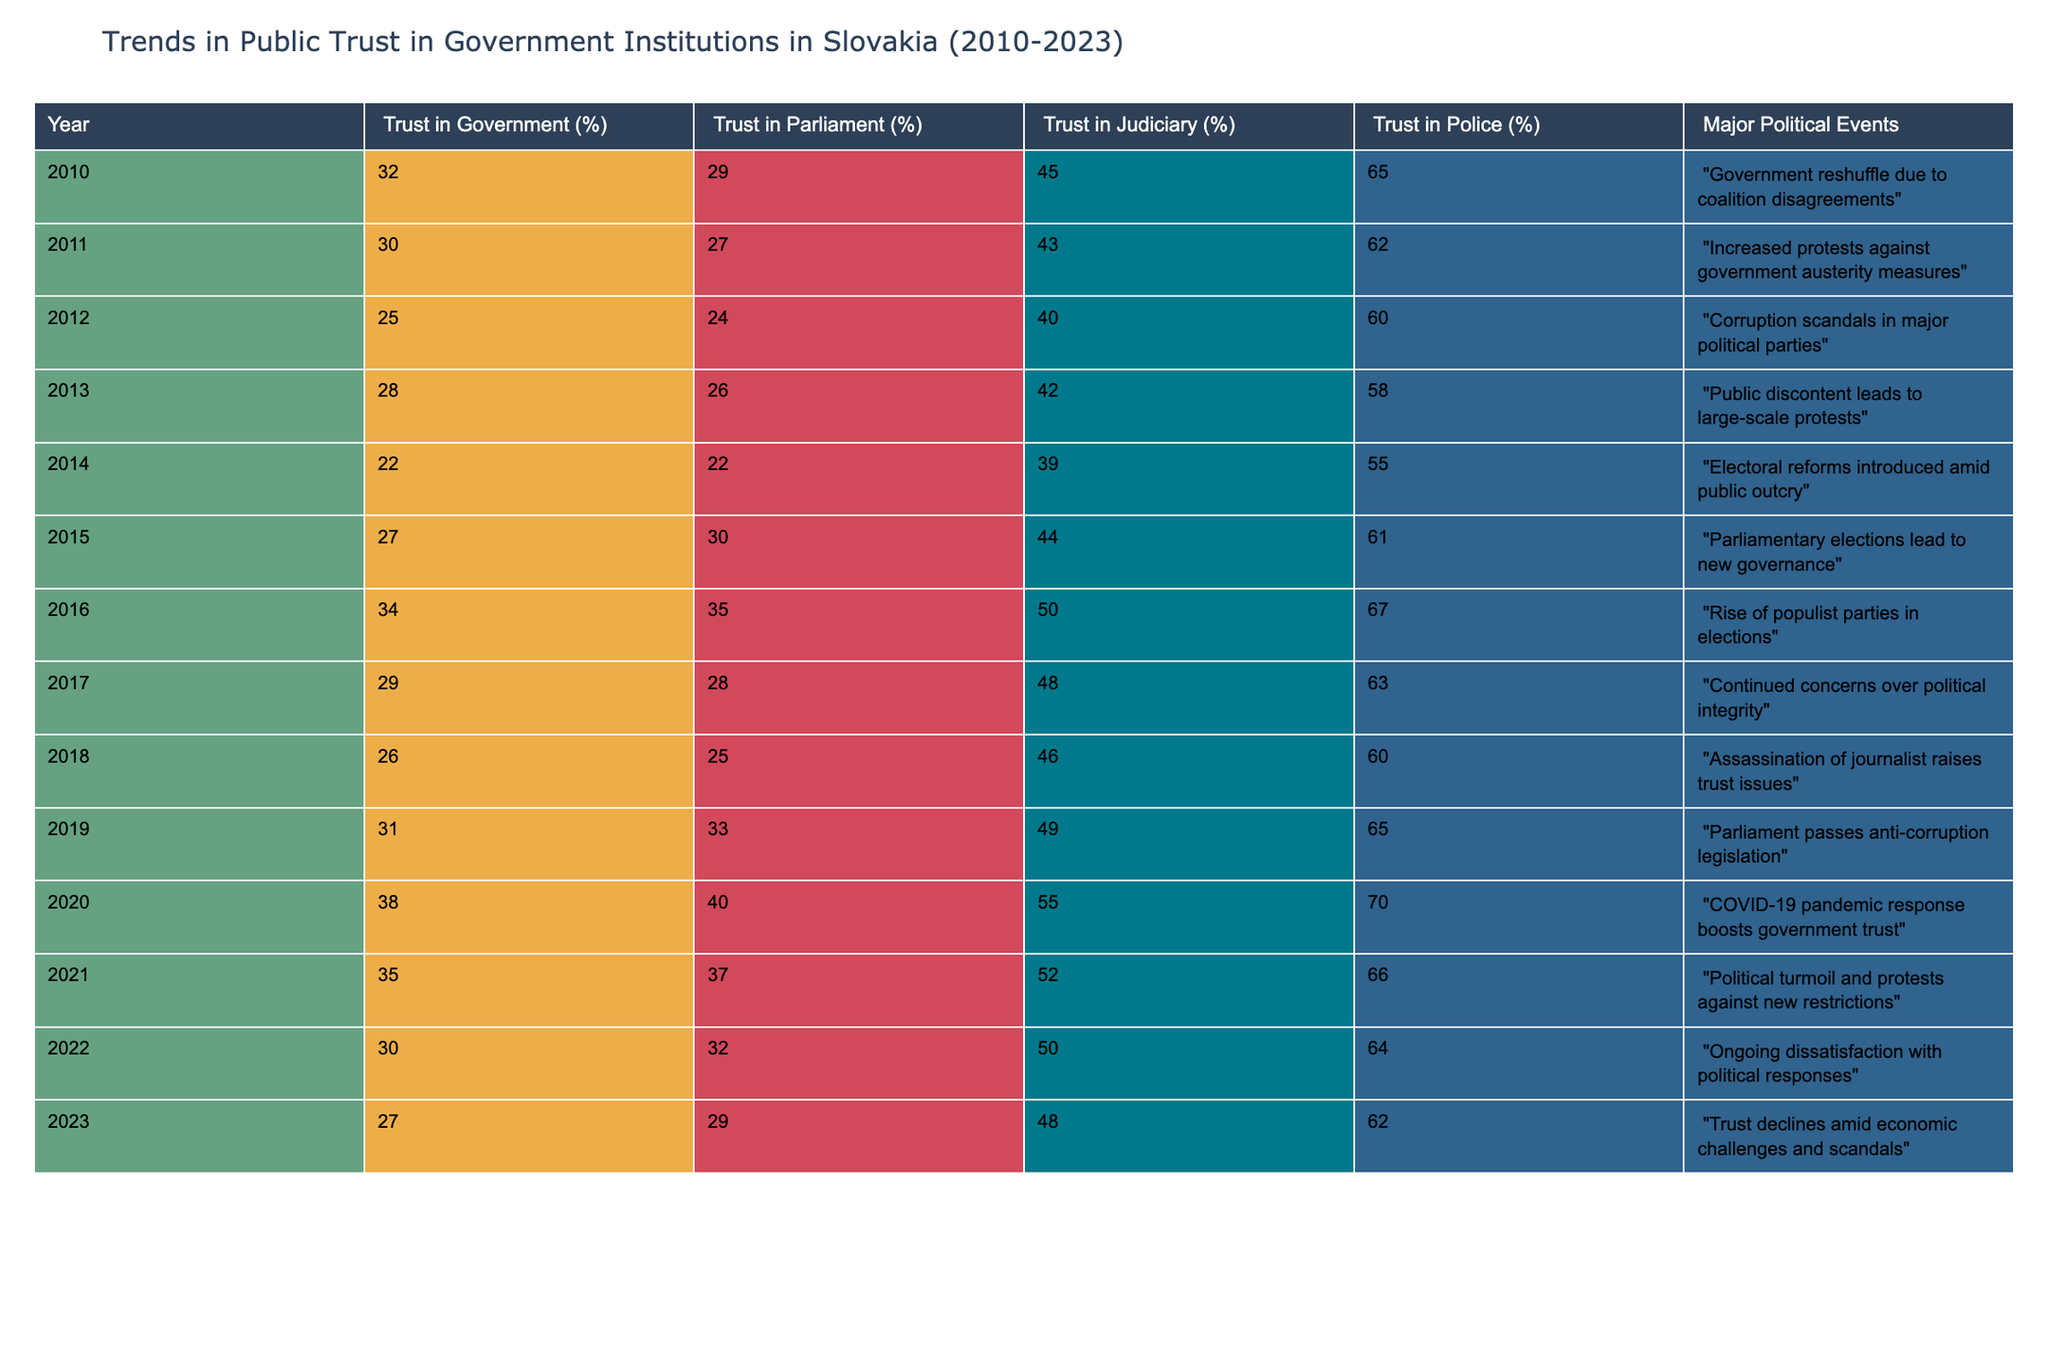What was the trust percentage in the government in 2010? In the table, we look at the row for the year 2010, where the trust in government is recorded as 32%.
Answer: 32% Which institution had the highest trust percentage in 2015? In 2015, we compare all the institutions: Trust in Government is 27%, Parliament is 30%, Judiciary is 44%, and Police is 61%. The highest is the Police at 61%.
Answer: Police: 61% What is the difference in trust in the judiciary from 2012 to 2020? In the table, the trust in the judiciary in 2012 is 40%, and in 2020, it is 55%. The difference is 55 - 40 = 15%.
Answer: 15% Was there an increase in trust in parliament from 2014 to 2015? In 2014, trust in parliament was 22%. In 2015, it increased to 30%. Since 30 > 22, it confirms there was an increase.
Answer: Yes What was the average trust in the police from 2010 to 2015? The trust in police for the years 2010 to 2015 are: 65, 62, 60, 55, 61. The sum is 65 + 62 + 60 + 55 + 61 = 303. There are 5 data points, so the average is 303 / 5 = 60.6.
Answer: 60.6 Which year saw the highest trust in government? Checking the table, the highest trust in government was in 2020 with a percentage of 38%.
Answer: 2020: 38% What was the trend in public trust from 2016 to 2023? We look at the trust in government from 2016 (34%) to 2023 (27%). The percentage decreased from 34 to 27. Thus, the trend shows a decline in trust over these years.
Answer: Decline Which political event in 2020 contributed to a boost in public trust? According to the table, the COVID-19 pandemic response in 2020 boosted government trust.
Answer: COVID-19 pandemic response How did trust in the parliament change from 2019 to 2023? In 2019, trust in parliament was 33%, and by 2023, it decreased to 29%. The change is from 33 to 29. Thus, trust in parliament decreased.
Answer: Decreased 